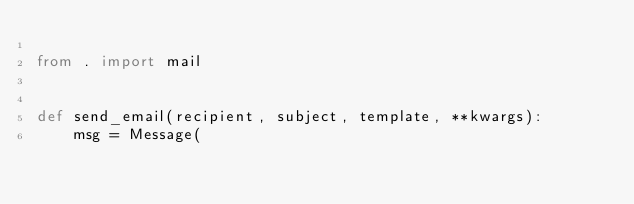Convert code to text. <code><loc_0><loc_0><loc_500><loc_500><_Python_>
from . import mail


def send_email(recipient, subject, template, **kwargs):
    msg = Message(</code> 